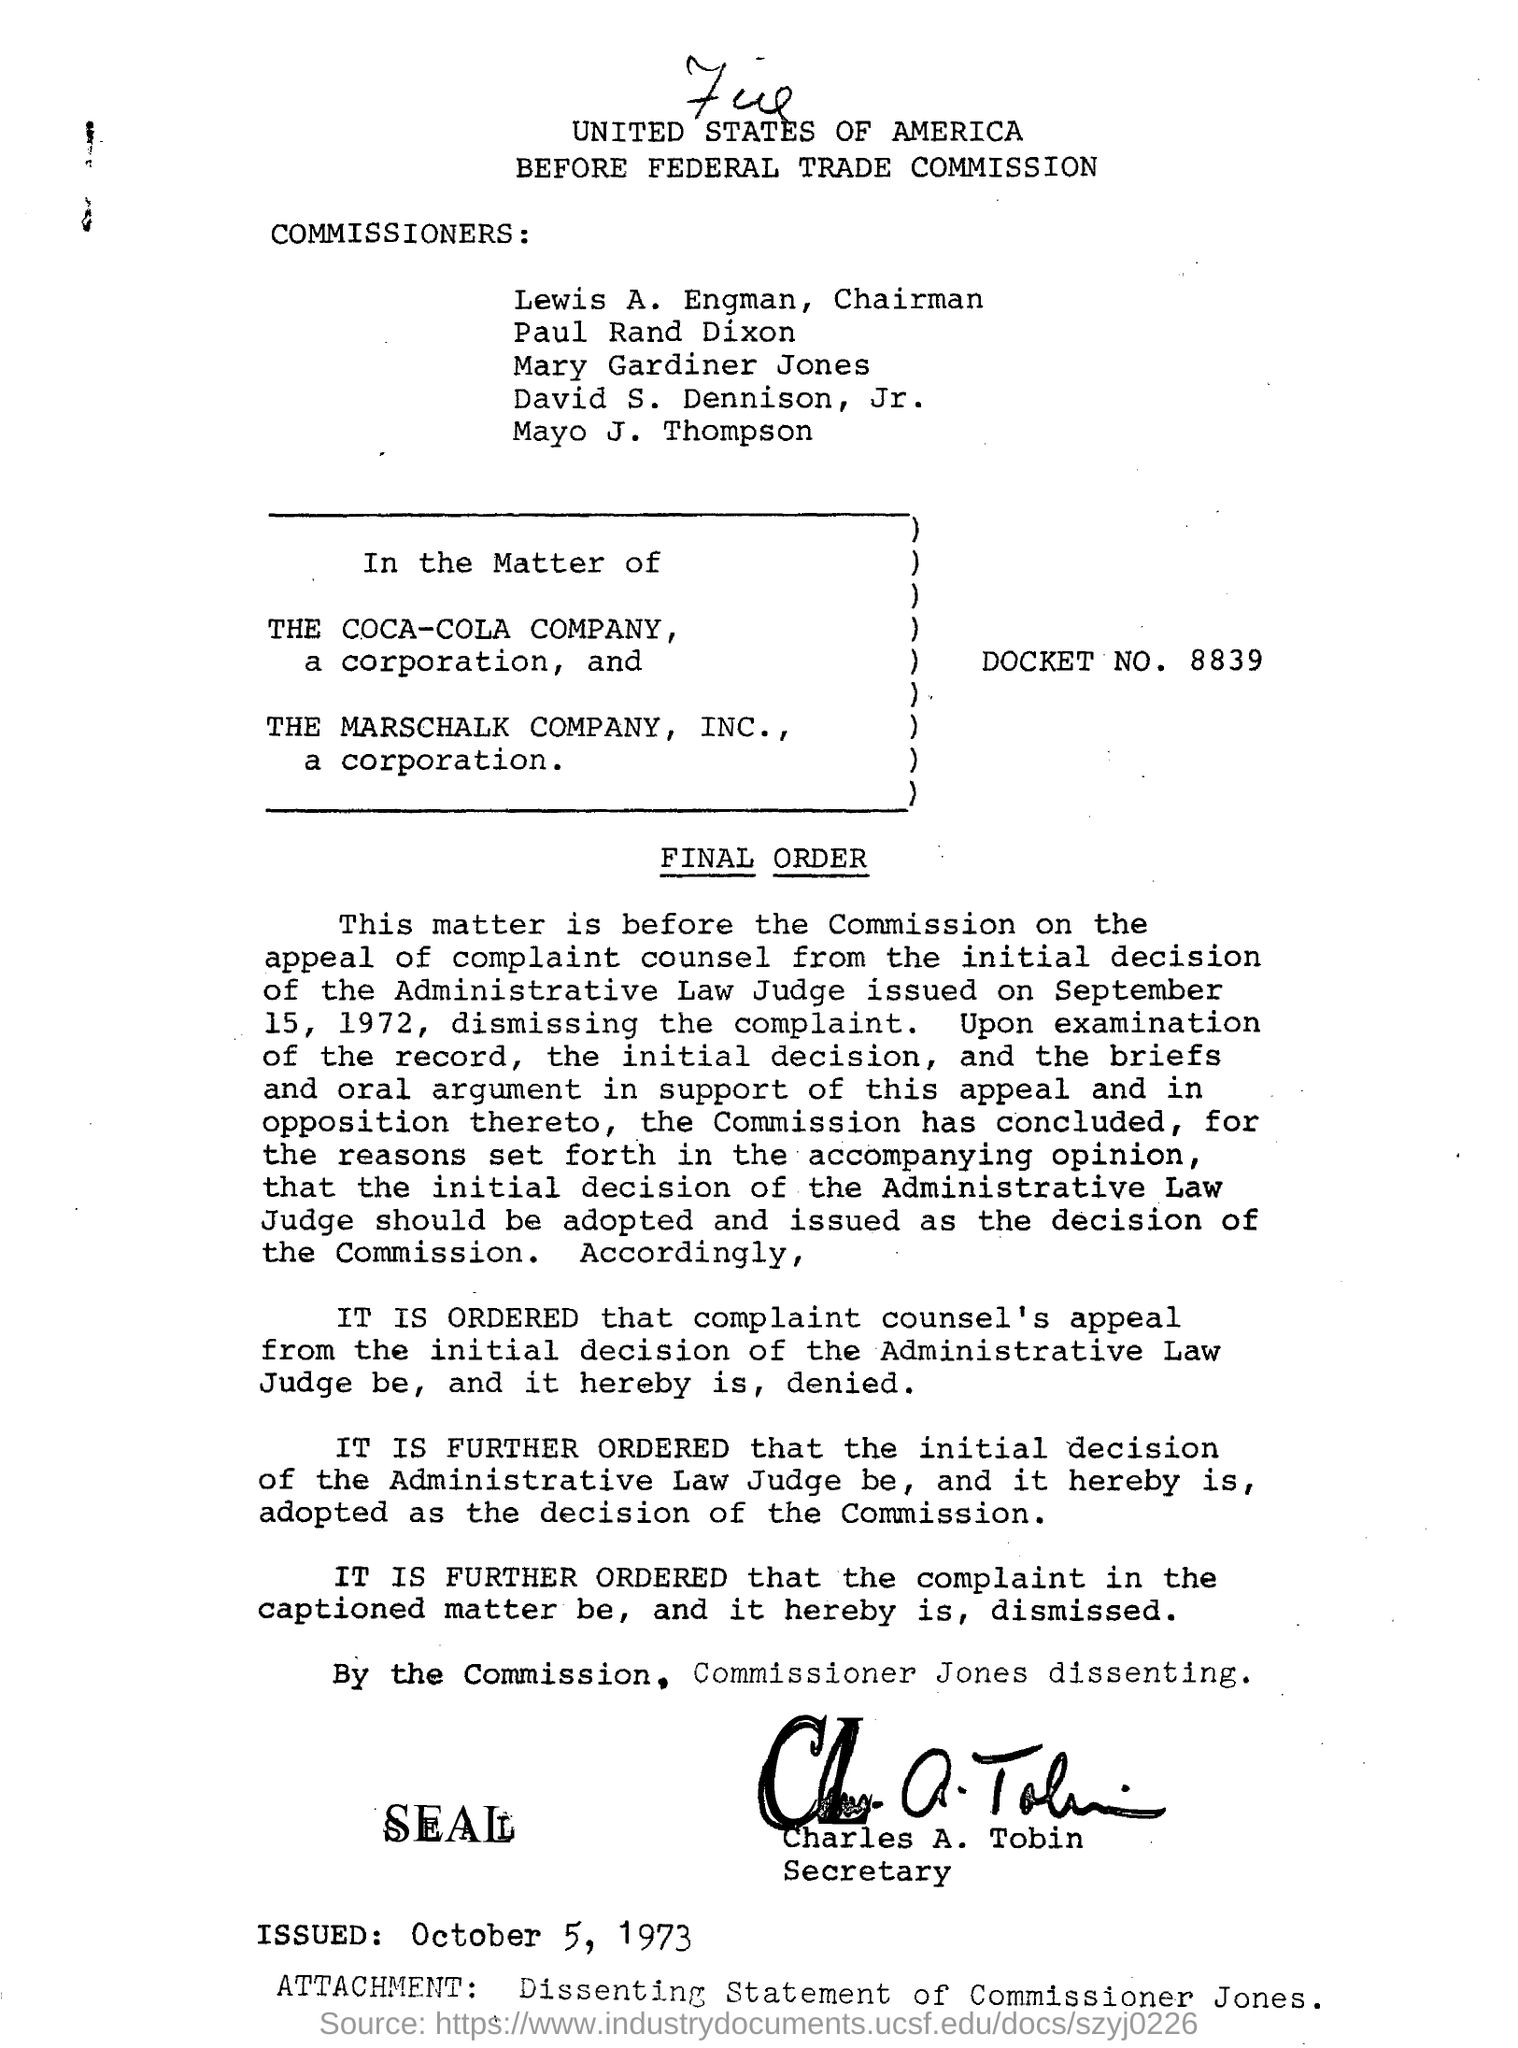Indicate a few pertinent items in this graphic. The question "What is the DOCKET NO? 8839.." is asking for information about a document with the number 8839. Charles A. Tobin is the secretary. 